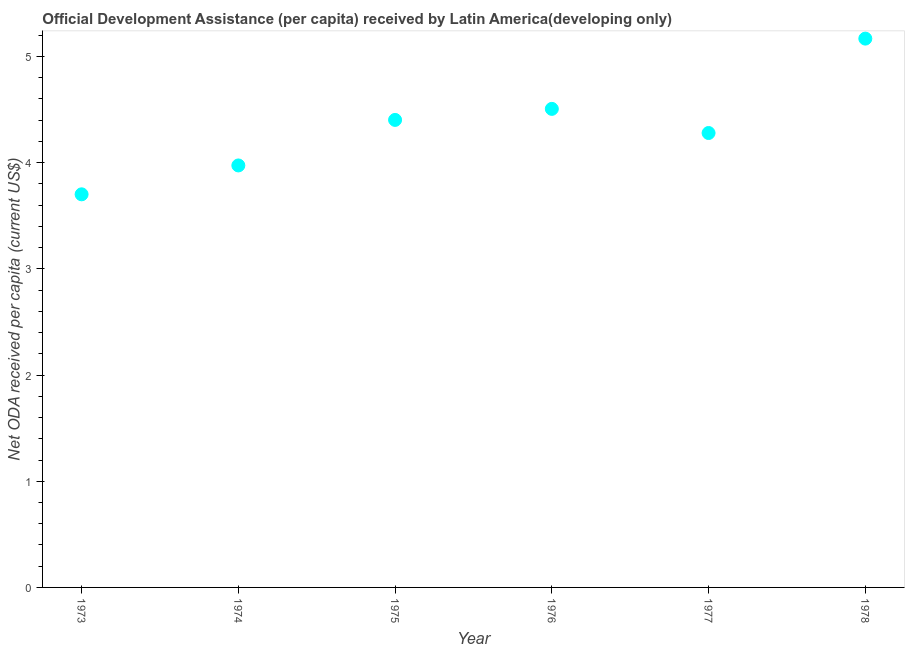What is the net oda received per capita in 1977?
Provide a short and direct response. 4.28. Across all years, what is the maximum net oda received per capita?
Ensure brevity in your answer.  5.17. Across all years, what is the minimum net oda received per capita?
Keep it short and to the point. 3.7. In which year was the net oda received per capita maximum?
Make the answer very short. 1978. What is the sum of the net oda received per capita?
Give a very brief answer. 26.03. What is the difference between the net oda received per capita in 1976 and 1977?
Provide a succinct answer. 0.23. What is the average net oda received per capita per year?
Keep it short and to the point. 4.34. What is the median net oda received per capita?
Keep it short and to the point. 4.34. In how many years, is the net oda received per capita greater than 2.8 US$?
Keep it short and to the point. 6. Do a majority of the years between 1978 and 1974 (inclusive) have net oda received per capita greater than 4.8 US$?
Give a very brief answer. Yes. What is the ratio of the net oda received per capita in 1976 to that in 1977?
Make the answer very short. 1.05. Is the net oda received per capita in 1975 less than that in 1977?
Ensure brevity in your answer.  No. Is the difference between the net oda received per capita in 1973 and 1974 greater than the difference between any two years?
Keep it short and to the point. No. What is the difference between the highest and the second highest net oda received per capita?
Give a very brief answer. 0.66. What is the difference between the highest and the lowest net oda received per capita?
Offer a very short reply. 1.47. In how many years, is the net oda received per capita greater than the average net oda received per capita taken over all years?
Give a very brief answer. 3. What is the difference between two consecutive major ticks on the Y-axis?
Your response must be concise. 1. Does the graph contain grids?
Keep it short and to the point. No. What is the title of the graph?
Offer a terse response. Official Development Assistance (per capita) received by Latin America(developing only). What is the label or title of the Y-axis?
Your answer should be compact. Net ODA received per capita (current US$). What is the Net ODA received per capita (current US$) in 1973?
Your answer should be compact. 3.7. What is the Net ODA received per capita (current US$) in 1974?
Your answer should be very brief. 3.97. What is the Net ODA received per capita (current US$) in 1975?
Provide a short and direct response. 4.4. What is the Net ODA received per capita (current US$) in 1976?
Provide a short and direct response. 4.51. What is the Net ODA received per capita (current US$) in 1977?
Give a very brief answer. 4.28. What is the Net ODA received per capita (current US$) in 1978?
Provide a short and direct response. 5.17. What is the difference between the Net ODA received per capita (current US$) in 1973 and 1974?
Make the answer very short. -0.27. What is the difference between the Net ODA received per capita (current US$) in 1973 and 1975?
Ensure brevity in your answer.  -0.7. What is the difference between the Net ODA received per capita (current US$) in 1973 and 1976?
Keep it short and to the point. -0.8. What is the difference between the Net ODA received per capita (current US$) in 1973 and 1977?
Give a very brief answer. -0.58. What is the difference between the Net ODA received per capita (current US$) in 1973 and 1978?
Your answer should be very brief. -1.47. What is the difference between the Net ODA received per capita (current US$) in 1974 and 1975?
Give a very brief answer. -0.43. What is the difference between the Net ODA received per capita (current US$) in 1974 and 1976?
Keep it short and to the point. -0.53. What is the difference between the Net ODA received per capita (current US$) in 1974 and 1977?
Your answer should be very brief. -0.31. What is the difference between the Net ODA received per capita (current US$) in 1974 and 1978?
Your answer should be compact. -1.19. What is the difference between the Net ODA received per capita (current US$) in 1975 and 1976?
Provide a short and direct response. -0.1. What is the difference between the Net ODA received per capita (current US$) in 1975 and 1977?
Offer a terse response. 0.12. What is the difference between the Net ODA received per capita (current US$) in 1975 and 1978?
Your answer should be very brief. -0.77. What is the difference between the Net ODA received per capita (current US$) in 1976 and 1977?
Make the answer very short. 0.23. What is the difference between the Net ODA received per capita (current US$) in 1976 and 1978?
Provide a succinct answer. -0.66. What is the difference between the Net ODA received per capita (current US$) in 1977 and 1978?
Your answer should be very brief. -0.89. What is the ratio of the Net ODA received per capita (current US$) in 1973 to that in 1974?
Provide a succinct answer. 0.93. What is the ratio of the Net ODA received per capita (current US$) in 1973 to that in 1975?
Ensure brevity in your answer.  0.84. What is the ratio of the Net ODA received per capita (current US$) in 1973 to that in 1976?
Give a very brief answer. 0.82. What is the ratio of the Net ODA received per capita (current US$) in 1973 to that in 1977?
Make the answer very short. 0.86. What is the ratio of the Net ODA received per capita (current US$) in 1973 to that in 1978?
Your answer should be very brief. 0.72. What is the ratio of the Net ODA received per capita (current US$) in 1974 to that in 1975?
Ensure brevity in your answer.  0.9. What is the ratio of the Net ODA received per capita (current US$) in 1974 to that in 1976?
Provide a succinct answer. 0.88. What is the ratio of the Net ODA received per capita (current US$) in 1974 to that in 1977?
Provide a short and direct response. 0.93. What is the ratio of the Net ODA received per capita (current US$) in 1974 to that in 1978?
Your answer should be very brief. 0.77. What is the ratio of the Net ODA received per capita (current US$) in 1975 to that in 1976?
Provide a short and direct response. 0.98. What is the ratio of the Net ODA received per capita (current US$) in 1975 to that in 1978?
Give a very brief answer. 0.85. What is the ratio of the Net ODA received per capita (current US$) in 1976 to that in 1977?
Your response must be concise. 1.05. What is the ratio of the Net ODA received per capita (current US$) in 1976 to that in 1978?
Your response must be concise. 0.87. What is the ratio of the Net ODA received per capita (current US$) in 1977 to that in 1978?
Offer a terse response. 0.83. 